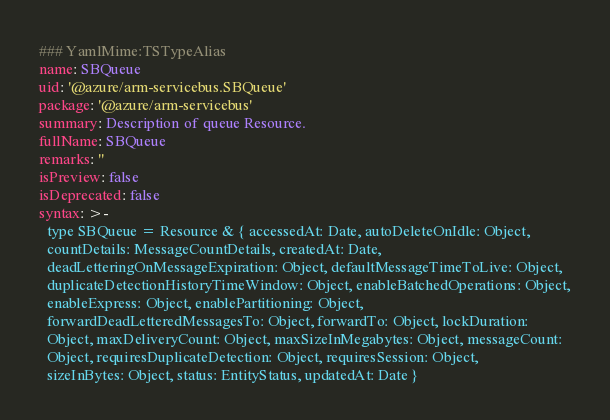<code> <loc_0><loc_0><loc_500><loc_500><_YAML_>### YamlMime:TSTypeAlias
name: SBQueue
uid: '@azure/arm-servicebus.SBQueue'
package: '@azure/arm-servicebus'
summary: Description of queue Resource.
fullName: SBQueue
remarks: ''
isPreview: false
isDeprecated: false
syntax: >-
  type SBQueue = Resource & { accessedAt: Date, autoDeleteOnIdle: Object,
  countDetails: MessageCountDetails, createdAt: Date,
  deadLetteringOnMessageExpiration: Object, defaultMessageTimeToLive: Object,
  duplicateDetectionHistoryTimeWindow: Object, enableBatchedOperations: Object,
  enableExpress: Object, enablePartitioning: Object,
  forwardDeadLetteredMessagesTo: Object, forwardTo: Object, lockDuration:
  Object, maxDeliveryCount: Object, maxSizeInMegabytes: Object, messageCount:
  Object, requiresDuplicateDetection: Object, requiresSession: Object,
  sizeInBytes: Object, status: EntityStatus, updatedAt: Date }
</code> 